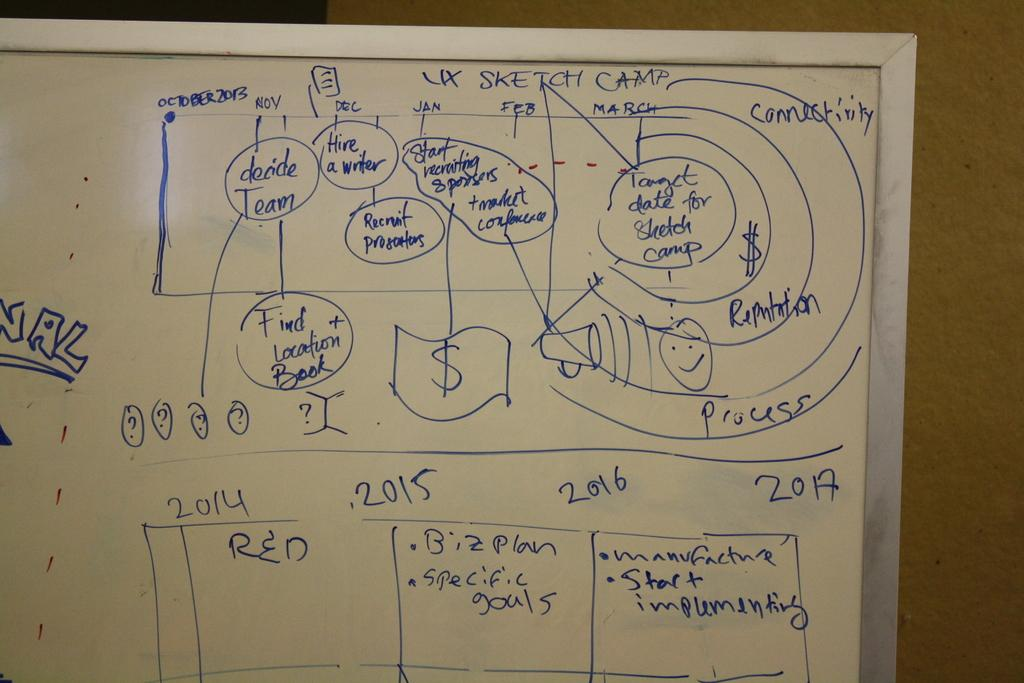<image>
Render a clear and concise summary of the photo. A whiteboard that is has a title called Sketch Camp. 